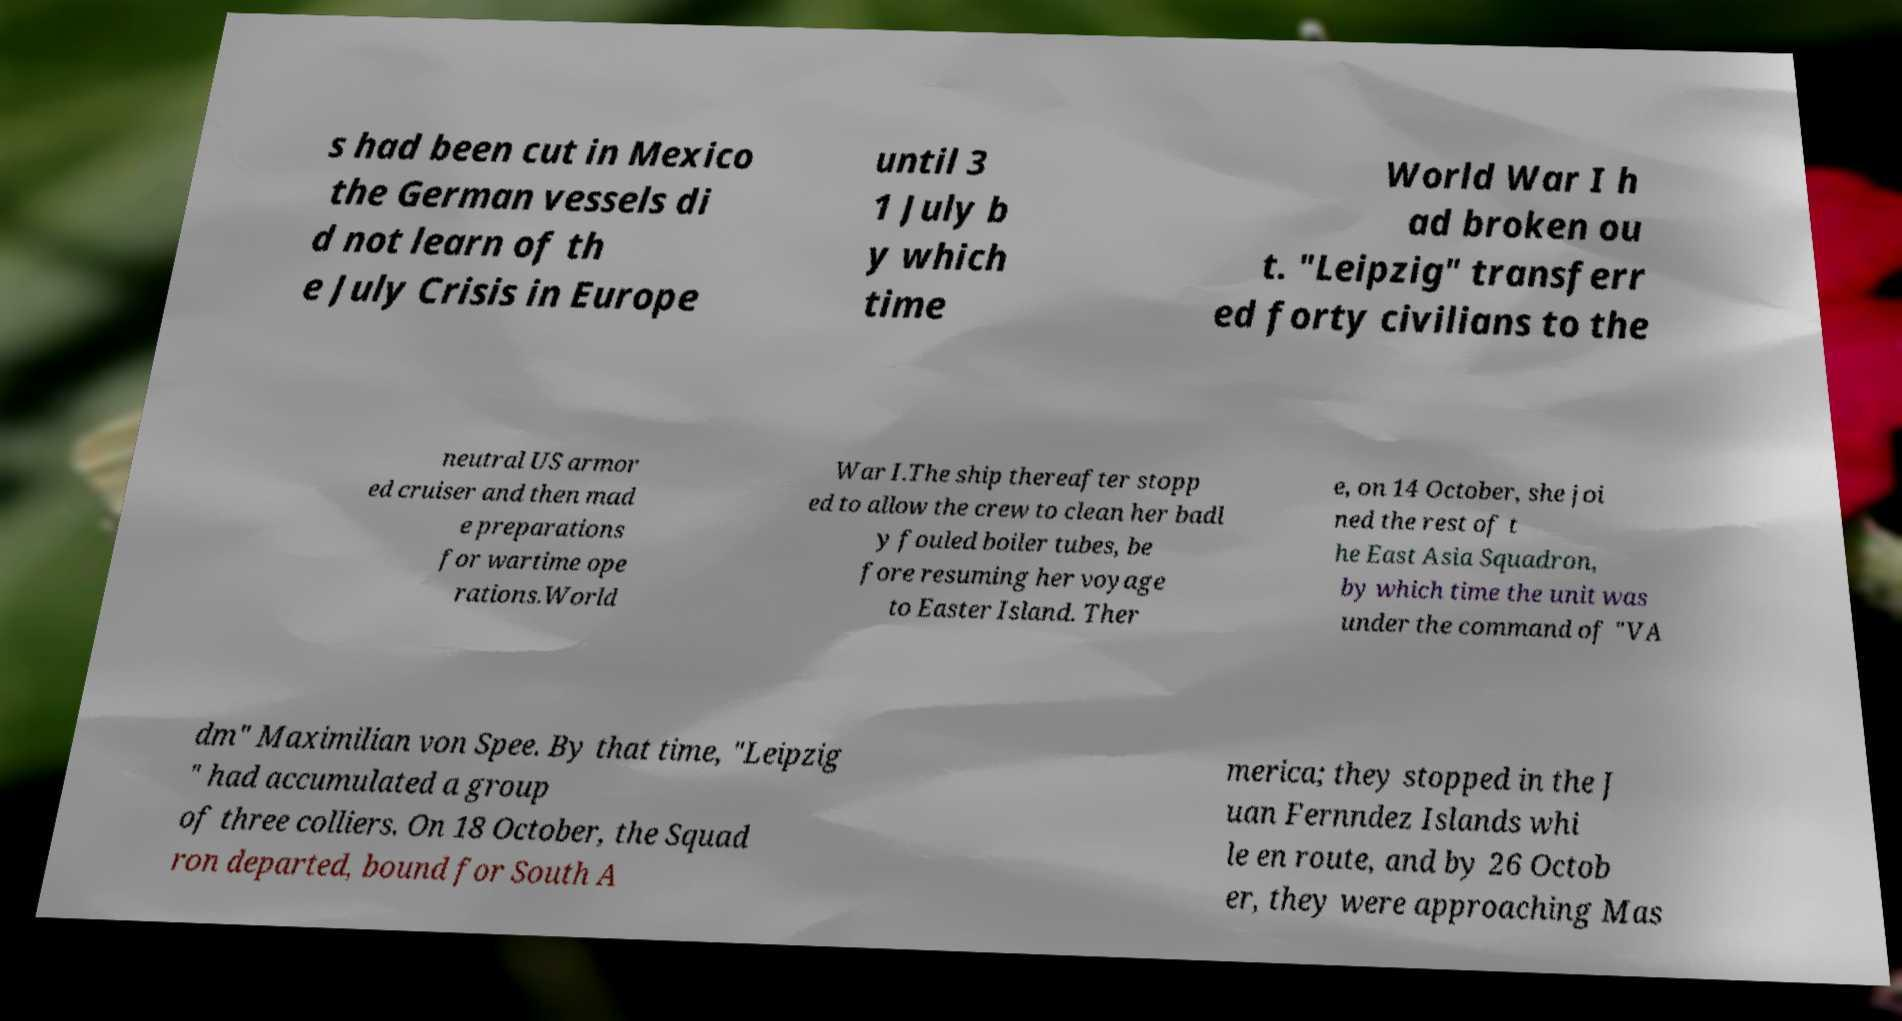What messages or text are displayed in this image? I need them in a readable, typed format. s had been cut in Mexico the German vessels di d not learn of th e July Crisis in Europe until 3 1 July b y which time World War I h ad broken ou t. "Leipzig" transferr ed forty civilians to the neutral US armor ed cruiser and then mad e preparations for wartime ope rations.World War I.The ship thereafter stopp ed to allow the crew to clean her badl y fouled boiler tubes, be fore resuming her voyage to Easter Island. Ther e, on 14 October, she joi ned the rest of t he East Asia Squadron, by which time the unit was under the command of "VA dm" Maximilian von Spee. By that time, "Leipzig " had accumulated a group of three colliers. On 18 October, the Squad ron departed, bound for South A merica; they stopped in the J uan Fernndez Islands whi le en route, and by 26 Octob er, they were approaching Mas 